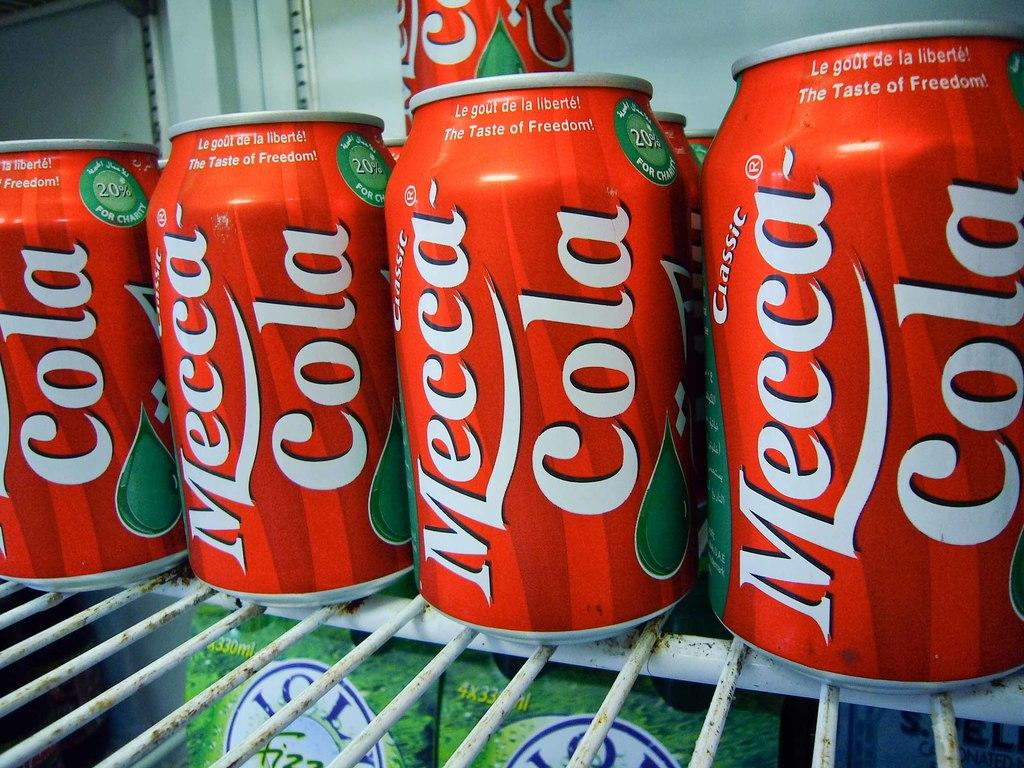Provide a one-sentence caption for the provided image. Bunch of cans of Mecca Cola that is in a red can. 